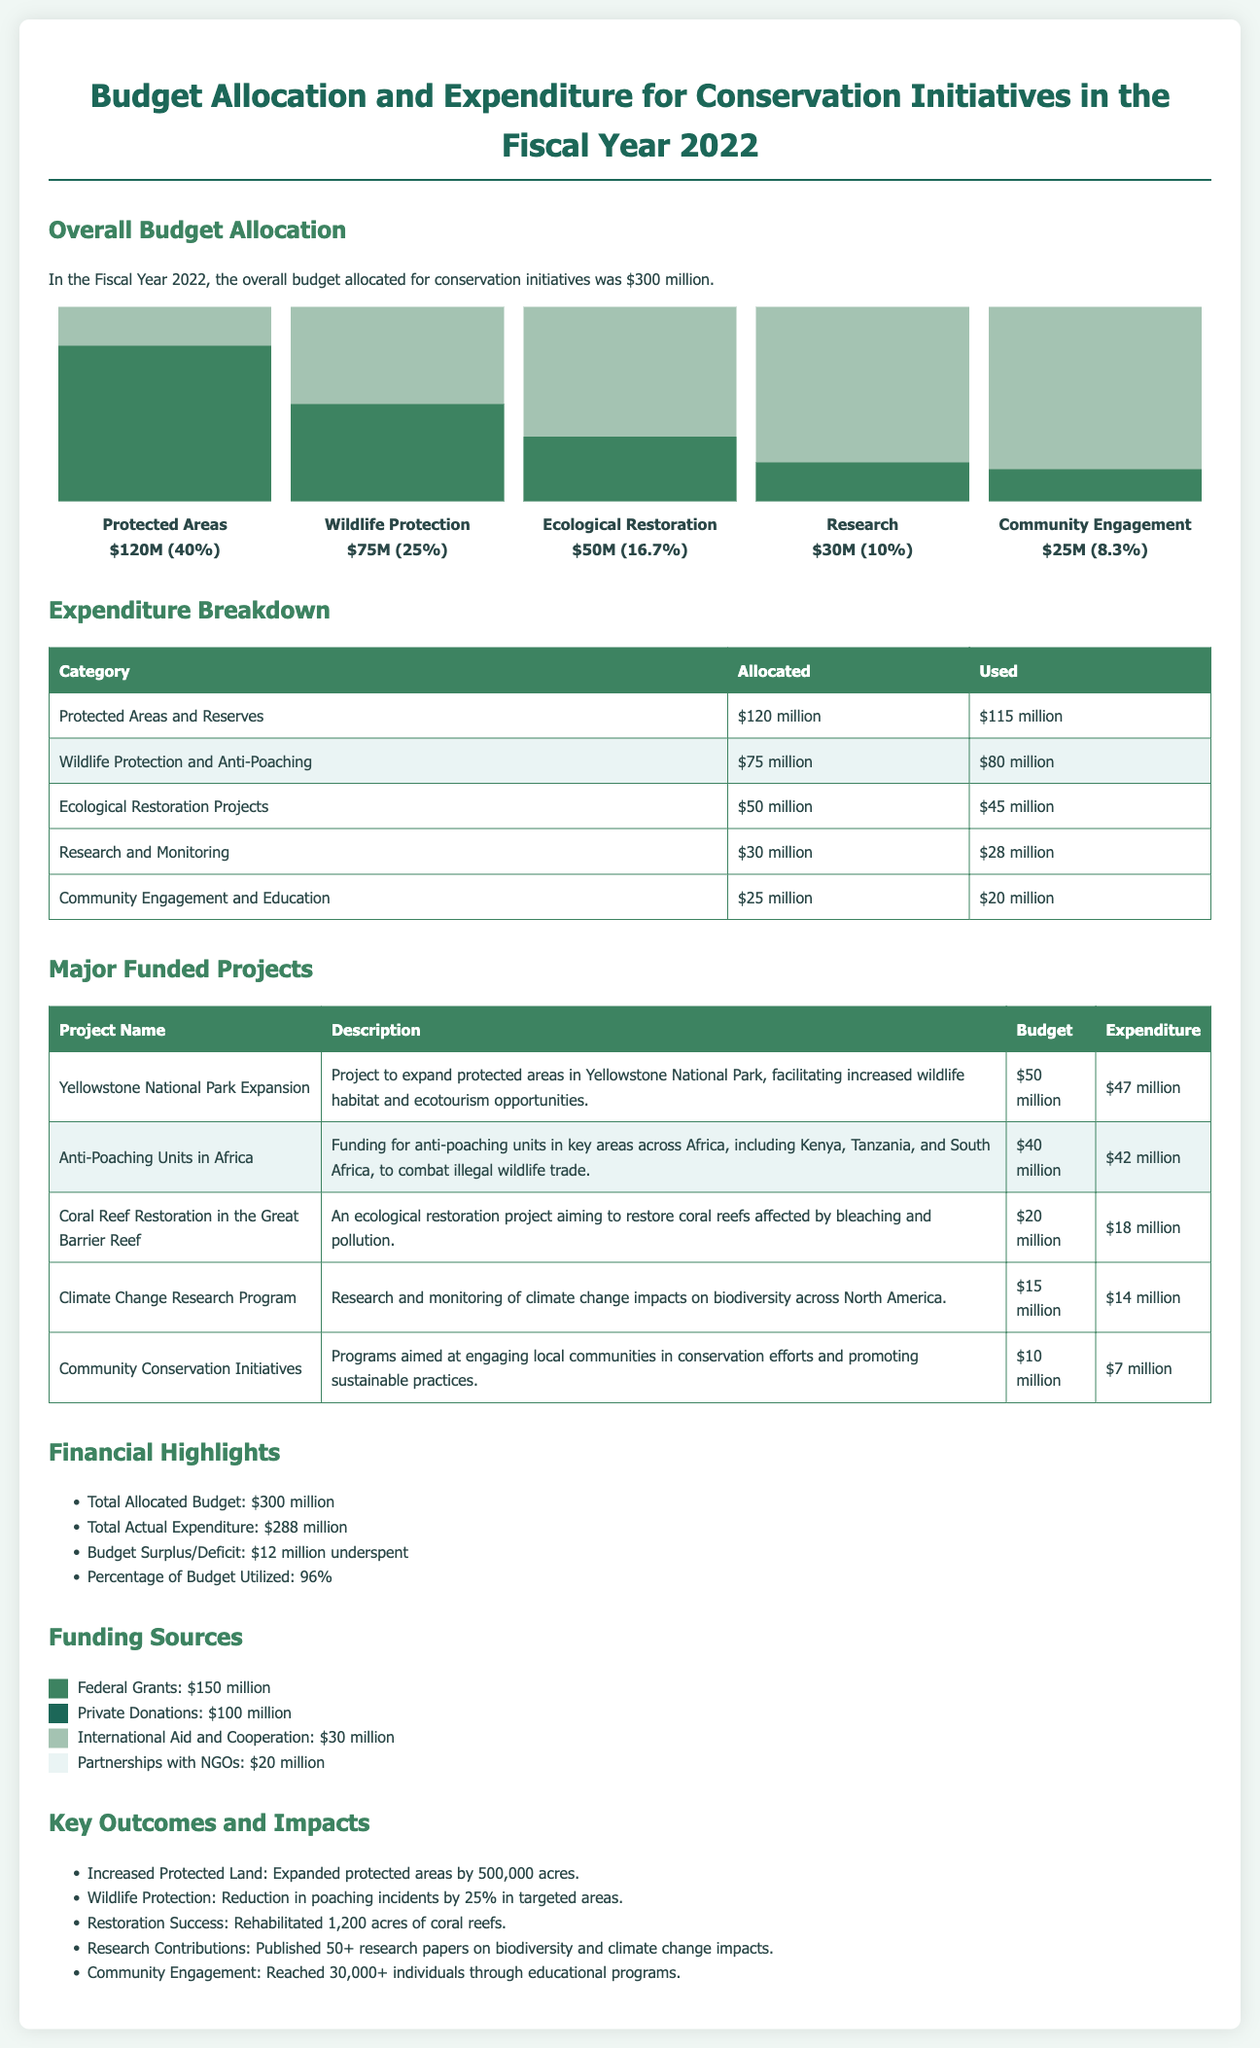what was the total budget allocated for conservation initiatives in 2022? The document states that the overall budget allocated for conservation initiatives was $300 million in the Fiscal Year 2022.
Answer: $300 million how much was spent on Wildlife Protection? According to the expenditure breakdown, the amount used for Wildlife Protection and Anti-Poaching was $80 million.
Answer: $80 million what percentage of the budget was utilized? The document states that the percentage of the budget utilized was 96%.
Answer: 96% which project had the highest budget? The project with the highest budget listed is the Yellowstone National Park Expansion with a budget of $50 million.
Answer: Yellowstone National Park Expansion how many acres of protected land were increased? The key outcomes state that protected areas were expanded by 500,000 acres.
Answer: 500,000 acres what was the budget for Community Engagement initiatives? The budget allocated for Community Engagement and Education was $25 million.
Answer: $25 million which funding source contributed the least? The document lists Partnerships with NGOs as the funding source that contributed the least, with an amount of $20 million.
Answer: $20 million how much was underspent in the conservation budget? It is mentioned that there was a $12 million underspent in the budget.
Answer: $12 million which project related to coral reef restoration? The document indicates that the Coral Reef Restoration in the Great Barrier Reef was the project related to coral reef restoration.
Answer: Coral Reef Restoration in the Great Barrier Reef 